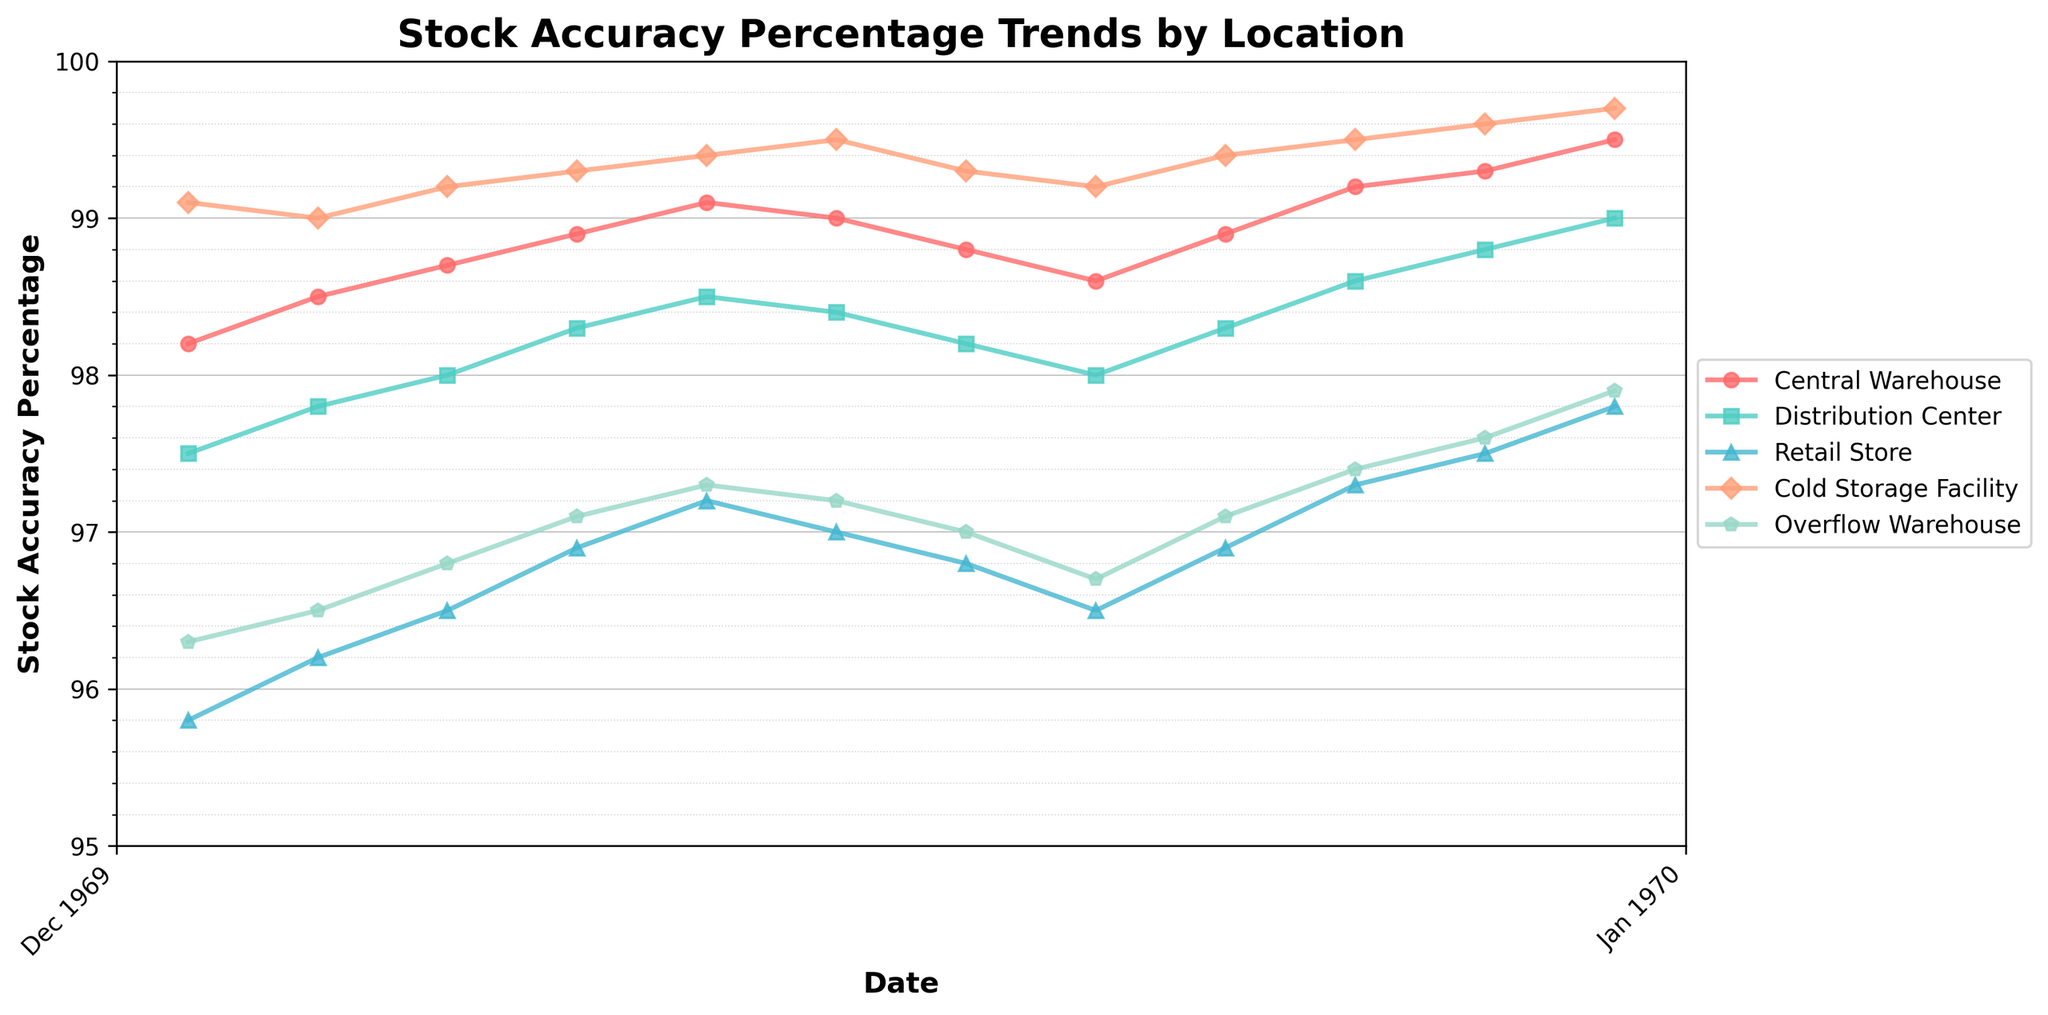What trend can be observed in the stock accuracy percentage at the Central Warehouse from January to December 2023? The data shows an upward trend in stock accuracy percentage at the Central Warehouse, starting at 98.2% in January 2023 and ending at 99.5% in December 2023.
Answer: An upward trend In which month did the Retail Store achieve the highest stock accuracy percentage? The Retail Store achieved the highest stock accuracy percentage in December 2023, which is 97.8%.
Answer: December 2023 By how much did the stock accuracy increase in the Overflow Warehouse from February to December 2023? The Overflow Warehouse's stock accuracy increased from 96.5% in February to 97.9% in December. The increase is 97.9% - 96.5% = 1.4%.
Answer: 1.4% Which storage location had the most consistent stock accuracy percentage throughout the year? The Cold Storage Facility had the most consistent stock accuracy percentage, varying only between 99.0% and 99.7%.
Answer: Cold Storage Facility Compare the stock accuracy percentage trends between the Distribution Center and the Overflow Warehouse. Which showed greater variability? The Distribution Center's stock accuracy percentage ranged from 97.5% to 99.0%, while the Overflow Warehouse ranged from 96.3% to 97.9%, indicating that the Overflow Warehouse showed slightly greater variability.
Answer: Overflow Warehouse What is the average stock accuracy percentage for the Retail Store over the year 2023? Sum the monthly percentages and divide by 12: (95.8 + 96.2 + 96.5 + 96.9 + 97.2 + 97.0 + 96.8 + 96.5 + 96.9 + 97.3 + 97.5 + 97.8) / 12 = 96.83%.
Answer: 96.83% How did the stock accuracy percentage of the Cold Storage Facility change between March and July 2023? In March 2023, it was 99.2%, and in July 2023, it was 99.3%, showing a slight increase of 0.1%.
Answer: Slight increase Identify the month and storage location where the lowest stock accuracy percentage was recorded. The lowest stock accuracy percentage was recorded in January 2023 at the Retail Store, which was 95.8%.
Answer: January 2023, Retail Store What is the overall trend for the Distribution Center from January to December 2023? The Distribution Center shows an upward trend from January (97.5%) to December (99.0%).
Answer: Upward trend 